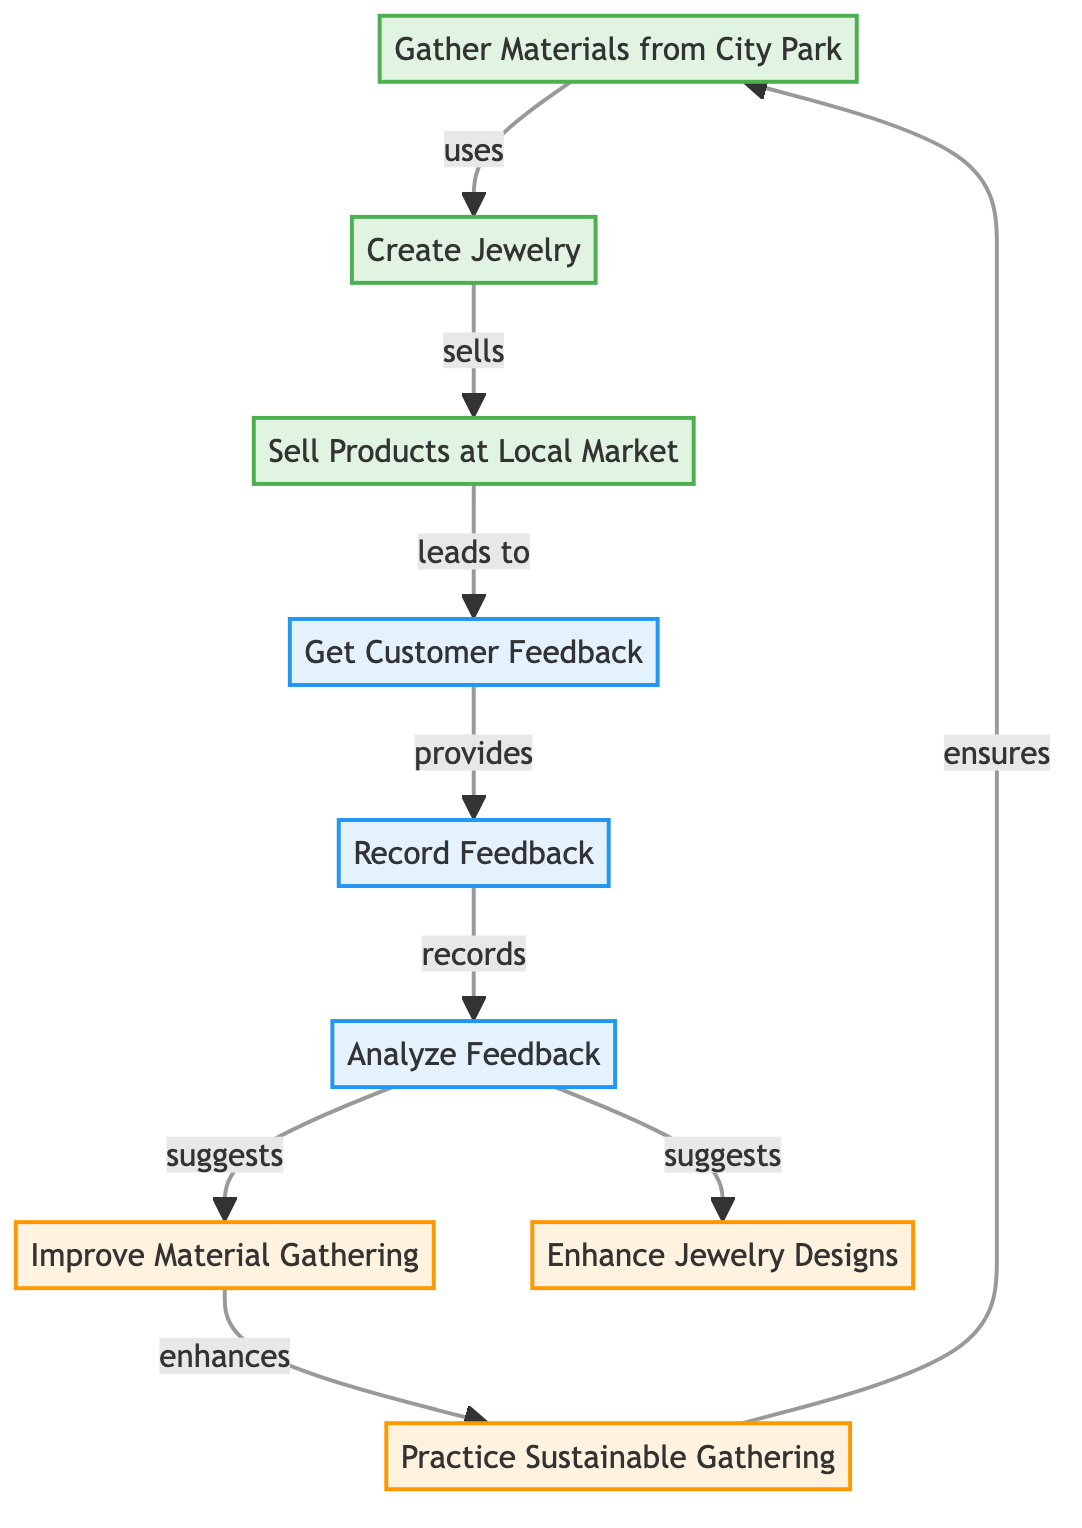What is the starting point of the process? The diagram begins with the "Gather Materials from City Park" node, which is the initial action taken in the feedback loop.
Answer: Gather Materials from City Park How many nodes are in the diagram? By counting each unique element labeled within the diagram, there are a total of nine nodes that depict various stages of the supplier and customer feedback loop.
Answer: Nine What action leads to getting customer feedback? The action that directly leads to getting customer feedback in the diagram is "Sell Products at Local Market," indicating that selling products triggers feedback collection.
Answer: Sell Products at Local Market What suggestion does analyzing feedback provide regarding materials? Analyzing feedback suggests "Improve Material Gathering," indicating that customer insights can lead to enhancements in how materials are sourced.
Answer: Improve Material Gathering What connection exists between analyzing feedback and enhancing designs? The diagram shows a directional flow where analyzing feedback "suggests" enhancements for jewelry designs, indicating that customer input can improve product aesthetics.
Answer: Suggests Which node ensures sustainable gathering practices? The node "Practice Sustainable Gathering" is connected to "Improve Material Gathering," showing that sustainability in gathering practices is a result of material improvements.
Answer: Practice Sustainable Gathering What is the relationship between gathering materials and creating jewelry? The connection shown is that the gathering of materials "uses" the sourced elements to create jewelry, indicating that material quality impacts product creation.
Answer: Uses How does the cycle conclude with sustainable practices? The diagram shows that sustainable practices ensure that the cycle of gathering materials is maintained, creating a continuous loop of improvement and sustainability.
Answer: Ensures 